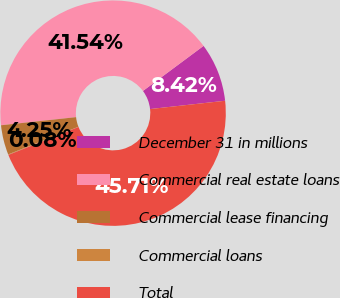<chart> <loc_0><loc_0><loc_500><loc_500><pie_chart><fcel>December 31 in millions<fcel>Commercial real estate loans<fcel>Commercial lease financing<fcel>Commercial loans<fcel>Total<nl><fcel>8.42%<fcel>41.54%<fcel>4.25%<fcel>0.08%<fcel>45.71%<nl></chart> 